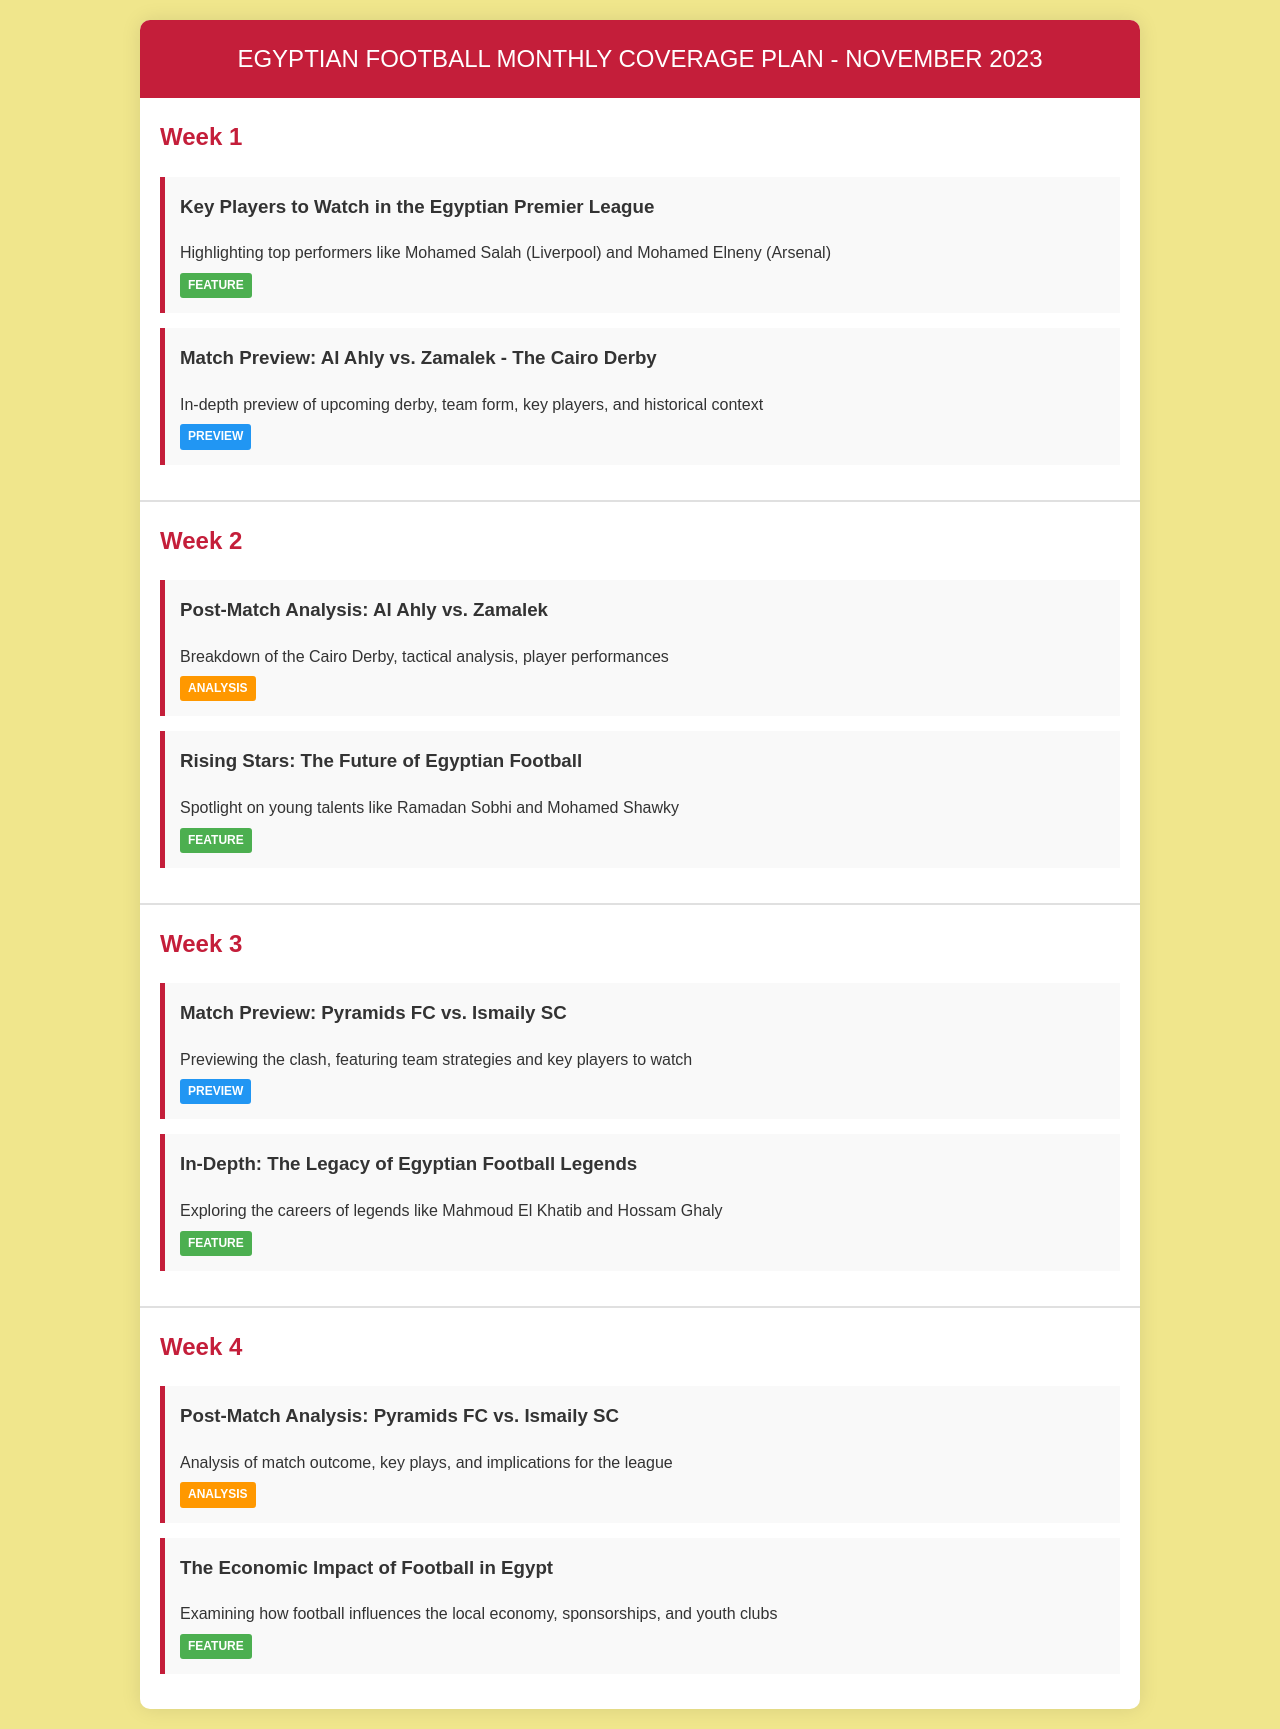What is the title of the document? The title is stated in the <title> tag within the document, which is "Egyptian Football Monthly Coverage Plan".
Answer: Egyptian Football Monthly Coverage Plan How many weeks are covered in the document? The document lists coverage for four weeks, showing weekly articles and topics.
Answer: 4 Which team is featured in the match preview for Week 1? Information about the match preview in Week 1 mentions Al Ahly and Zamalek as the teams involved.
Answer: Al Ahly vs. Zamalek What topic is discussed in the Week 2 post-match analysis? The post-match analysis for Week 2 specifically mentions the Cairo Derby between Al Ahly and Zamalek.
Answer: Al Ahly vs. Zamalek Name one key player highlighted in the Week 1 feature article. The feature article in Week 1 highlights top performers, including Mohamed Salah.
Answer: Mohamed Salah What is the theme of the article in Week 3 titled "In-Depth: The Legacy of Egyptian Football Legends"? The article explores the careers of notable figures in Egyptian football, focusing on past football legends.
Answer: Egyptian Football Legends What economic aspect does the feature article in Week 4 examine? The document mentions that the Week 4 article explores how football impacts the local economy in Egypt.
Answer: Local economy What type of article is "Rising Stars: The Future of Egyptian Football"? The document classifies the "Rising Stars" article in Week 2 as a feature.
Answer: Feature 